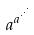Convert formula to latex. <formula><loc_0><loc_0><loc_500><loc_500>a ^ { a ^ { \cdot ^ { \cdot ^ { \cdot } } } }</formula> 